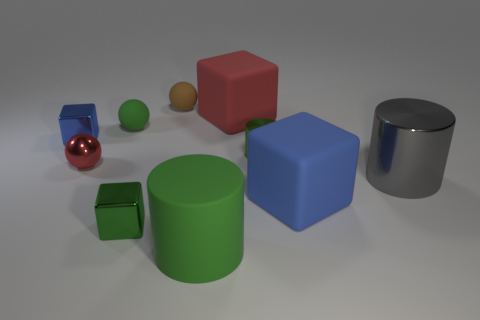There is a blue object that is left of the tiny green rubber object; is it the same shape as the large gray object?
Ensure brevity in your answer.  No. What color is the ball that is in front of the tiny green cylinder?
Keep it short and to the point. Red. What number of other things are there of the same size as the green metal cylinder?
Your answer should be very brief. 5. Is there anything else that is the same shape as the big green object?
Provide a short and direct response. Yes. Are there the same number of small red things to the right of the metal sphere and tiny brown matte things?
Your answer should be very brief. No. What number of cylinders are the same material as the tiny red ball?
Your answer should be compact. 2. There is a large thing that is the same material as the small blue thing; what color is it?
Offer a very short reply. Gray. Do the gray metal object and the brown rubber thing have the same shape?
Your answer should be very brief. No. Is there a tiny brown matte sphere behind the small sphere that is behind the tiny matte object in front of the brown ball?
Your answer should be compact. No. How many small metal balls have the same color as the rubber cylinder?
Keep it short and to the point. 0. 